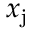<formula> <loc_0><loc_0><loc_500><loc_500>x _ { j }</formula> 